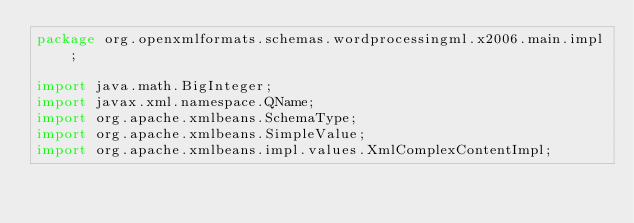<code> <loc_0><loc_0><loc_500><loc_500><_Java_>package org.openxmlformats.schemas.wordprocessingml.x2006.main.impl;

import java.math.BigInteger;
import javax.xml.namespace.QName;
import org.apache.xmlbeans.SchemaType;
import org.apache.xmlbeans.SimpleValue;
import org.apache.xmlbeans.impl.values.XmlComplexContentImpl;</code> 